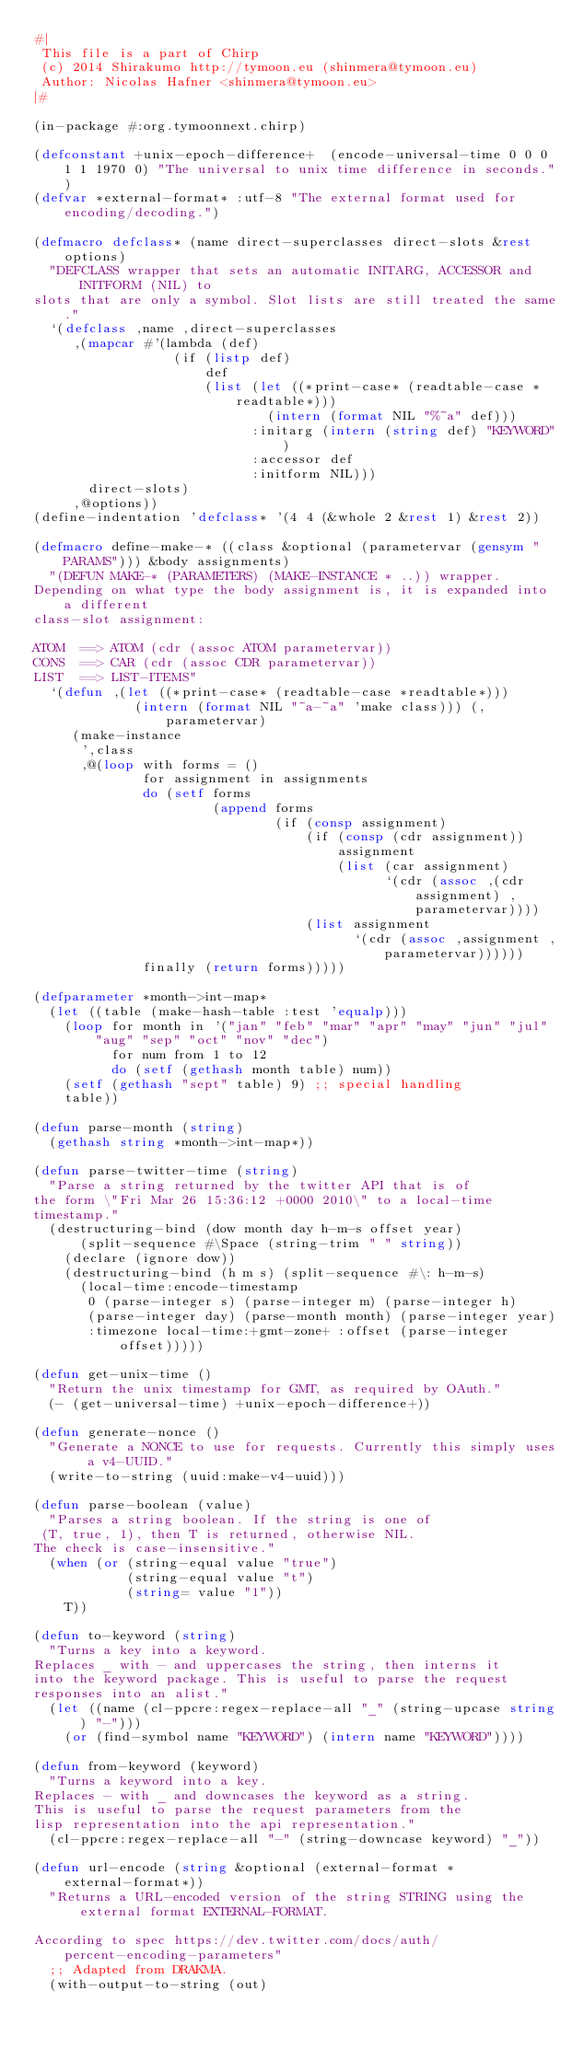<code> <loc_0><loc_0><loc_500><loc_500><_Lisp_>#|
 This file is a part of Chirp
 (c) 2014 Shirakumo http://tymoon.eu (shinmera@tymoon.eu)
 Author: Nicolas Hafner <shinmera@tymoon.eu>
|#

(in-package #:org.tymoonnext.chirp)

(defconstant +unix-epoch-difference+  (encode-universal-time 0 0 0 1 1 1970 0) "The universal to unix time difference in seconds.")
(defvar *external-format* :utf-8 "The external format used for encoding/decoding.")

(defmacro defclass* (name direct-superclasses direct-slots &rest options)
  "DEFCLASS wrapper that sets an automatic INITARG, ACCESSOR and INITFORM (NIL) to
slots that are only a symbol. Slot lists are still treated the same."
  `(defclass ,name ,direct-superclasses
     ,(mapcar #'(lambda (def)
                  (if (listp def)
                      def
                      (list (let ((*print-case* (readtable-case *readtable*)))
                              (intern (format NIL "%~a" def)))
                            :initarg (intern (string def) "KEYWORD")
                            :accessor def
                            :initform NIL)))
       direct-slots)
     ,@options))
(define-indentation 'defclass* '(4 4 (&whole 2 &rest 1) &rest 2))

(defmacro define-make-* ((class &optional (parametervar (gensym "PARAMS"))) &body assignments)
  "(DEFUN MAKE-* (PARAMETERS) (MAKE-INSTANCE * ..)) wrapper.
Depending on what type the body assignment is, it is expanded into a different
class-slot assignment:

ATOM  ==> ATOM (cdr (assoc ATOM parametervar))
CONS  ==> CAR (cdr (assoc CDR parametervar))
LIST  ==> LIST-ITEMS"
  `(defun ,(let ((*print-case* (readtable-case *readtable*)))
             (intern (format NIL "~a-~a" 'make class))) (,parametervar)
     (make-instance
      ',class
      ,@(loop with forms = ()
              for assignment in assignments
              do (setf forms
                       (append forms
                               (if (consp assignment)
                                   (if (consp (cdr assignment))
                                       assignment
                                       (list (car assignment)
                                             `(cdr (assoc ,(cdr assignment) ,parametervar))))
                                   (list assignment
                                         `(cdr (assoc ,assignment ,parametervar))))))
              finally (return forms)))))

(defparameter *month->int-map*
  (let ((table (make-hash-table :test 'equalp)))
    (loop for month in '("jan" "feb" "mar" "apr" "may" "jun" "jul" "aug" "sep" "oct" "nov" "dec")
          for num from 1 to 12
          do (setf (gethash month table) num))
    (setf (gethash "sept" table) 9) ;; special handling
    table))

(defun parse-month (string)
  (gethash string *month->int-map*))

(defun parse-twitter-time (string)
  "Parse a string returned by the twitter API that is of
the form \"Fri Mar 26 15:36:12 +0000 2010\" to a local-time
timestamp."
  (destructuring-bind (dow month day h-m-s offset year)
      (split-sequence #\Space (string-trim " " string))
    (declare (ignore dow))
    (destructuring-bind (h m s) (split-sequence #\: h-m-s)
      (local-time:encode-timestamp
       0 (parse-integer s) (parse-integer m) (parse-integer h)
       (parse-integer day) (parse-month month) (parse-integer year)
       :timezone local-time:+gmt-zone+ :offset (parse-integer offset)))))

(defun get-unix-time ()
  "Return the unix timestamp for GMT, as required by OAuth."
  (- (get-universal-time) +unix-epoch-difference+))

(defun generate-nonce ()
  "Generate a NONCE to use for requests. Currently this simply uses a v4-UUID."
  (write-to-string (uuid:make-v4-uuid)))

(defun parse-boolean (value)
  "Parses a string boolean. If the string is one of 
 (T, true, 1), then T is returned, otherwise NIL.
The check is case-insensitive."
  (when (or (string-equal value "true")
            (string-equal value "t")
            (string= value "1"))
    T))

(defun to-keyword (string)
  "Turns a key into a keyword.
Replaces _ with - and uppercases the string, then interns it
into the keyword package. This is useful to parse the request
responses into an alist."
  (let ((name (cl-ppcre:regex-replace-all "_" (string-upcase string) "-")))
    (or (find-symbol name "KEYWORD") (intern name "KEYWORD"))))

(defun from-keyword (keyword)
  "Turns a keyword into a key.
Replaces - with _ and downcases the keyword as a string.
This is useful to parse the request parameters from the
lisp representation into the api representation."
  (cl-ppcre:regex-replace-all "-" (string-downcase keyword) "_"))

(defun url-encode (string &optional (external-format *external-format*))
  "Returns a URL-encoded version of the string STRING using the external format EXTERNAL-FORMAT.

According to spec https://dev.twitter.com/docs/auth/percent-encoding-parameters"
  ;; Adapted from DRAKMA.
  (with-output-to-string (out)</code> 